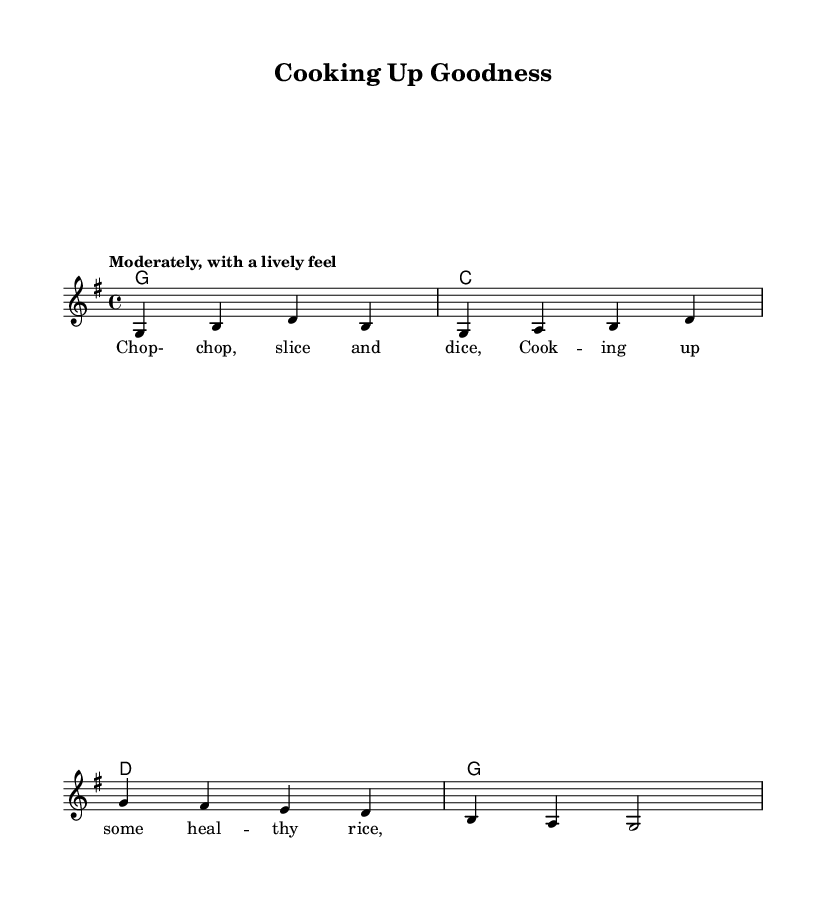What is the key signature of this music? The key signature is indicated by the initial part of the music and shows one sharp, which corresponds to the key of G major.
Answer: G major What is the time signature of this piece? The time signature appears at the beginning of the sheet music as 4/4, indicating four beats per measure.
Answer: 4/4 What is the tempo marking for this piece? The tempo marking is included in the header section, stating "Moderately, with a lively feel," which suggests a moderate speed with energy.
Answer: Moderately, with a lively feel How many measures are in the melody section? Counting the distinct segments in the melody, we can see there are four complete measures in total provided.
Answer: Four What type of music style does this piece represent? The lyrics and overall theme focusing on cooking healthy meals indicate that this music belongs to a folk style celebrating healthy cooking and good food habits.
Answer: Folk music What is the first lyric line of the verse? The first lyric can be found written below the melody in the lyric mode section and reads "Chop-chop, slice and dice," which introduces the theme of cooking.
Answer: Chop-chop, slice and dice What chord is used in the first measure? The chord symbols are listed under the melody; the first measure corresponds to a G major chord symbol.
Answer: G 